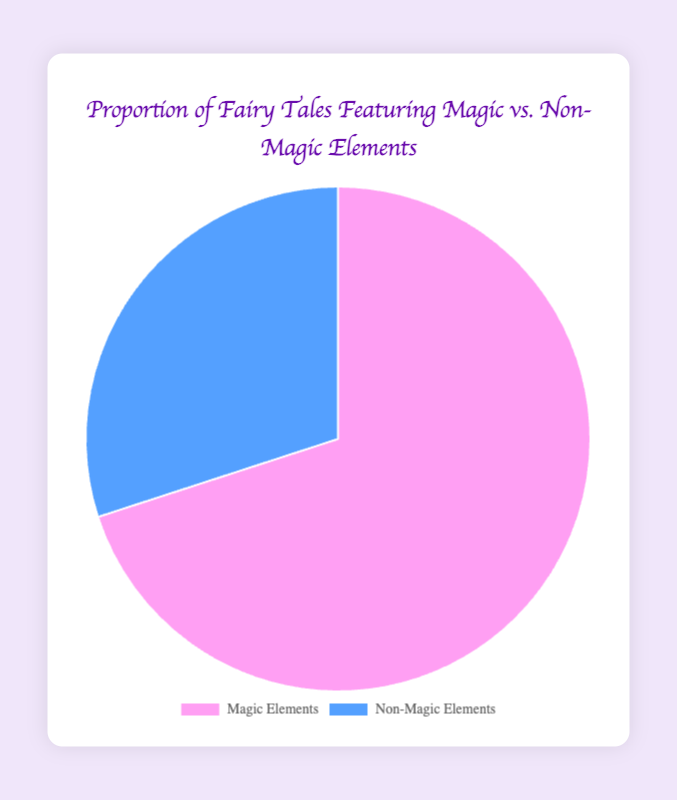What percentage of fairy tales feature magic elements? The pie chart labels indicate the proportion for "Magic Elements." The percentage shown for this section is clearly labeled as 70%.
Answer: 70% What's the difference in percentage between fairy tales with magic and those without? The percentages for "Magic Elements" and "Non-Magic Elements" are 70% and 30%, respectively. The difference is calculated by subtracting the smaller percentage from the larger one: 70% - 30% = 40%.
Answer: 40% Which category has the lesser representation in the chart? The chart has two categories: "Magic Elements" and "Non-Magic Elements". Among them, "Non-Magic Elements" has a smaller percentage, which is 30%, compared to 70% for "Magic Elements."
Answer: Non-Magic Elements What color represents the 'Non-Magic Elements' category in the pie chart? The visual attributes of the pie chart show that the "Non-Magic Elements" section is represented in blue color.
Answer: Blue If the total number of fairy tales is 100, how many tales feature magic elements? Given that 70% of fairy tales feature magic elements, and the total number of tales is 100, the number of magic element tales is calculated as 70% of 100: 0.70 * 100 = 70.
Answer: 70 Together, what percentage of fairy tales do not feature magic elements and those that do feature magic elements? The pie chart is divided into two parts: "Magic Elements" with 70% and "Non-Magic Elements" with 30%. The total percentage for any pie chart must add up to 100%. Thus, 70% + 30% = 100%.
Answer: 100% Which category takes up more space visually in the pie chart? The chart shows two sectors, with "Magic Elements" visually taking up more space than "Non-Magic Elements".
Answer: Magic Elements If 20 new fairy tales are added and all feature non-magic elements, what will be the new proportion of non-magic to total fairy tales assuming the above percentages are for an initial 100 tales? Initially, 30 tales feature non-magic elements out of 100. Adding 20 new non-magic tales makes it 50 non-magic tales out of a new total of 120 tales. The new proportion is (50/120)*100 which is approximately 41.67%.
Answer: Approximately 41.67% 